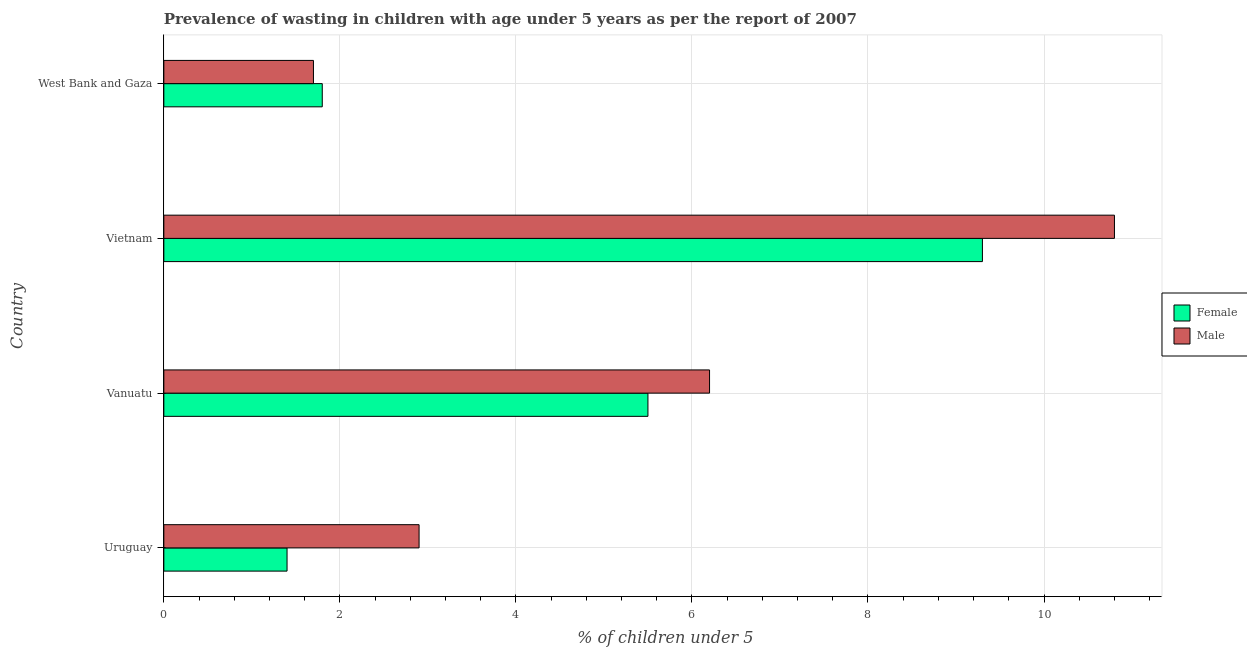Are the number of bars per tick equal to the number of legend labels?
Provide a succinct answer. Yes. Are the number of bars on each tick of the Y-axis equal?
Provide a short and direct response. Yes. How many bars are there on the 1st tick from the top?
Provide a short and direct response. 2. How many bars are there on the 1st tick from the bottom?
Make the answer very short. 2. What is the label of the 4th group of bars from the top?
Ensure brevity in your answer.  Uruguay. In how many cases, is the number of bars for a given country not equal to the number of legend labels?
Ensure brevity in your answer.  0. What is the percentage of undernourished female children in Vietnam?
Your response must be concise. 9.3. Across all countries, what is the maximum percentage of undernourished female children?
Make the answer very short. 9.3. Across all countries, what is the minimum percentage of undernourished female children?
Your answer should be compact. 1.4. In which country was the percentage of undernourished female children maximum?
Your answer should be compact. Vietnam. In which country was the percentage of undernourished female children minimum?
Offer a very short reply. Uruguay. What is the total percentage of undernourished male children in the graph?
Keep it short and to the point. 21.6. What is the difference between the percentage of undernourished female children in Uruguay and that in Vanuatu?
Provide a succinct answer. -4.1. What is the difference between the percentage of undernourished male children in West Bank and Gaza and the percentage of undernourished female children in Vanuatu?
Your response must be concise. -3.8. What is the average percentage of undernourished male children per country?
Your answer should be very brief. 5.4. What is the ratio of the percentage of undernourished female children in Vietnam to that in West Bank and Gaza?
Keep it short and to the point. 5.17. Is the percentage of undernourished female children in Vietnam less than that in West Bank and Gaza?
Provide a succinct answer. No. Is the difference between the percentage of undernourished male children in Uruguay and Vanuatu greater than the difference between the percentage of undernourished female children in Uruguay and Vanuatu?
Keep it short and to the point. Yes. What is the difference between the highest and the second highest percentage of undernourished female children?
Provide a short and direct response. 3.8. What is the difference between the highest and the lowest percentage of undernourished female children?
Ensure brevity in your answer.  7.9. In how many countries, is the percentage of undernourished female children greater than the average percentage of undernourished female children taken over all countries?
Ensure brevity in your answer.  2. Is the sum of the percentage of undernourished male children in Uruguay and Vanuatu greater than the maximum percentage of undernourished female children across all countries?
Make the answer very short. No. How many bars are there?
Your response must be concise. 8. Are all the bars in the graph horizontal?
Provide a short and direct response. Yes. What is the difference between two consecutive major ticks on the X-axis?
Offer a very short reply. 2. Does the graph contain any zero values?
Provide a succinct answer. No. Where does the legend appear in the graph?
Give a very brief answer. Center right. How are the legend labels stacked?
Provide a short and direct response. Vertical. What is the title of the graph?
Your answer should be compact. Prevalence of wasting in children with age under 5 years as per the report of 2007. What is the label or title of the X-axis?
Give a very brief answer.  % of children under 5. What is the label or title of the Y-axis?
Your response must be concise. Country. What is the  % of children under 5 of Female in Uruguay?
Offer a terse response. 1.4. What is the  % of children under 5 of Male in Uruguay?
Ensure brevity in your answer.  2.9. What is the  % of children under 5 in Female in Vanuatu?
Keep it short and to the point. 5.5. What is the  % of children under 5 of Male in Vanuatu?
Ensure brevity in your answer.  6.2. What is the  % of children under 5 in Female in Vietnam?
Your response must be concise. 9.3. What is the  % of children under 5 of Male in Vietnam?
Your answer should be very brief. 10.8. What is the  % of children under 5 of Female in West Bank and Gaza?
Give a very brief answer. 1.8. What is the  % of children under 5 of Male in West Bank and Gaza?
Provide a succinct answer. 1.7. Across all countries, what is the maximum  % of children under 5 of Female?
Your answer should be very brief. 9.3. Across all countries, what is the maximum  % of children under 5 of Male?
Ensure brevity in your answer.  10.8. Across all countries, what is the minimum  % of children under 5 in Female?
Offer a terse response. 1.4. Across all countries, what is the minimum  % of children under 5 in Male?
Give a very brief answer. 1.7. What is the total  % of children under 5 of Female in the graph?
Keep it short and to the point. 18. What is the total  % of children under 5 in Male in the graph?
Provide a succinct answer. 21.6. What is the difference between the  % of children under 5 of Female in Uruguay and that in Vietnam?
Your response must be concise. -7.9. What is the difference between the  % of children under 5 in Female in Uruguay and that in West Bank and Gaza?
Ensure brevity in your answer.  -0.4. What is the difference between the  % of children under 5 of Female in Vanuatu and that in West Bank and Gaza?
Give a very brief answer. 3.7. What is the difference between the  % of children under 5 in Male in Vanuatu and that in West Bank and Gaza?
Give a very brief answer. 4.5. What is the difference between the  % of children under 5 of Female in Vietnam and that in West Bank and Gaza?
Offer a very short reply. 7.5. What is the difference between the  % of children under 5 in Male in Vietnam and that in West Bank and Gaza?
Offer a very short reply. 9.1. What is the difference between the  % of children under 5 of Female in Uruguay and the  % of children under 5 of Male in Vietnam?
Give a very brief answer. -9.4. What is the difference between the  % of children under 5 of Female in Vietnam and the  % of children under 5 of Male in West Bank and Gaza?
Ensure brevity in your answer.  7.6. What is the difference between the  % of children under 5 of Female and  % of children under 5 of Male in Uruguay?
Provide a succinct answer. -1.5. What is the difference between the  % of children under 5 in Female and  % of children under 5 in Male in Vanuatu?
Provide a short and direct response. -0.7. What is the difference between the  % of children under 5 of Female and  % of children under 5 of Male in West Bank and Gaza?
Give a very brief answer. 0.1. What is the ratio of the  % of children under 5 of Female in Uruguay to that in Vanuatu?
Offer a terse response. 0.25. What is the ratio of the  % of children under 5 of Male in Uruguay to that in Vanuatu?
Your response must be concise. 0.47. What is the ratio of the  % of children under 5 in Female in Uruguay to that in Vietnam?
Ensure brevity in your answer.  0.15. What is the ratio of the  % of children under 5 of Male in Uruguay to that in Vietnam?
Your answer should be very brief. 0.27. What is the ratio of the  % of children under 5 of Female in Uruguay to that in West Bank and Gaza?
Keep it short and to the point. 0.78. What is the ratio of the  % of children under 5 of Male in Uruguay to that in West Bank and Gaza?
Ensure brevity in your answer.  1.71. What is the ratio of the  % of children under 5 in Female in Vanuatu to that in Vietnam?
Ensure brevity in your answer.  0.59. What is the ratio of the  % of children under 5 of Male in Vanuatu to that in Vietnam?
Offer a terse response. 0.57. What is the ratio of the  % of children under 5 in Female in Vanuatu to that in West Bank and Gaza?
Give a very brief answer. 3.06. What is the ratio of the  % of children under 5 of Male in Vanuatu to that in West Bank and Gaza?
Make the answer very short. 3.65. What is the ratio of the  % of children under 5 in Female in Vietnam to that in West Bank and Gaza?
Your answer should be very brief. 5.17. What is the ratio of the  % of children under 5 of Male in Vietnam to that in West Bank and Gaza?
Your answer should be very brief. 6.35. What is the difference between the highest and the second highest  % of children under 5 in Male?
Offer a very short reply. 4.6. What is the difference between the highest and the lowest  % of children under 5 of Female?
Keep it short and to the point. 7.9. What is the difference between the highest and the lowest  % of children under 5 of Male?
Keep it short and to the point. 9.1. 